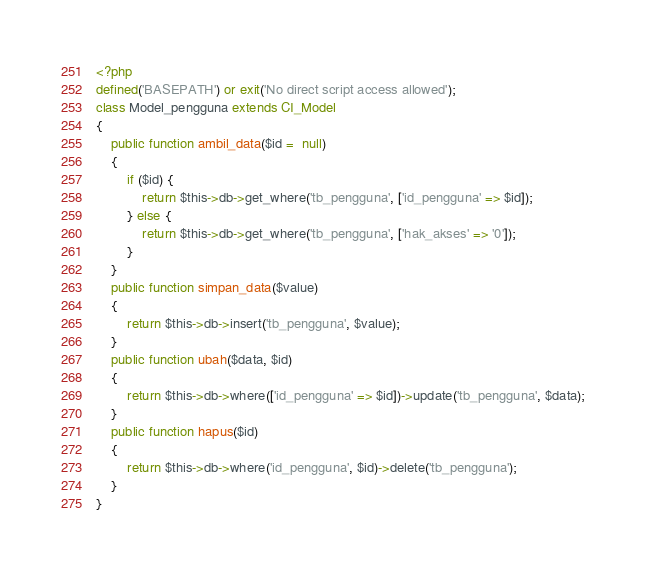<code> <loc_0><loc_0><loc_500><loc_500><_PHP_><?php
defined('BASEPATH') or exit('No direct script access allowed');
class Model_pengguna extends CI_Model
{
	public function ambil_data($id =  null)
	{
		if ($id) {
			return $this->db->get_where('tb_pengguna', ['id_pengguna' => $id]);
		} else {
			return $this->db->get_where('tb_pengguna', ['hak_akses' => '0']);
		}
	}
	public function simpan_data($value)
	{
		return $this->db->insert('tb_pengguna', $value);
	}
	public function ubah($data, $id)
	{
		return $this->db->where(['id_pengguna' => $id])->update('tb_pengguna', $data);
	}
	public function hapus($id)
	{
		return $this->db->where('id_pengguna', $id)->delete('tb_pengguna');
	}
}
</code> 